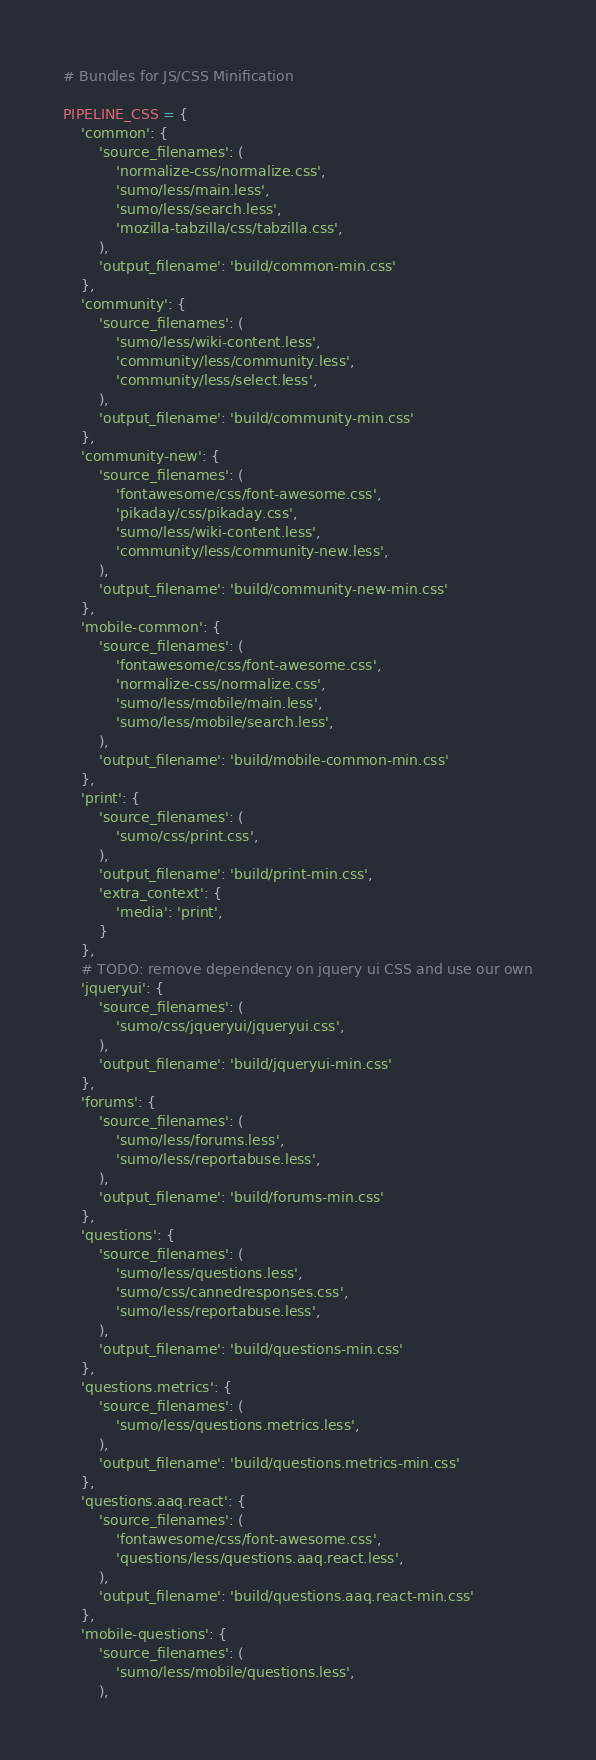<code> <loc_0><loc_0><loc_500><loc_500><_Python_># Bundles for JS/CSS Minification

PIPELINE_CSS = {
    'common': {
        'source_filenames': (
            'normalize-css/normalize.css',
            'sumo/less/main.less',
            'sumo/less/search.less',
            'mozilla-tabzilla/css/tabzilla.css',
        ),
        'output_filename': 'build/common-min.css'
    },
    'community': {
        'source_filenames': (
            'sumo/less/wiki-content.less',
            'community/less/community.less',
            'community/less/select.less',
        ),
        'output_filename': 'build/community-min.css'
    },
    'community-new': {
        'source_filenames': (
            'fontawesome/css/font-awesome.css',
            'pikaday/css/pikaday.css',
            'sumo/less/wiki-content.less',
            'community/less/community-new.less',
        ),
        'output_filename': 'build/community-new-min.css'
    },
    'mobile-common': {
        'source_filenames': (
            'fontawesome/css/font-awesome.css',
            'normalize-css/normalize.css',
            'sumo/less/mobile/main.less',
            'sumo/less/mobile/search.less',
        ),
        'output_filename': 'build/mobile-common-min.css'
    },
    'print': {
        'source_filenames': (
            'sumo/css/print.css',
        ),
        'output_filename': 'build/print-min.css',
        'extra_context': {
            'media': 'print',
        }
    },
    # TODO: remove dependency on jquery ui CSS and use our own
    'jqueryui': {
        'source_filenames': (
            'sumo/css/jqueryui/jqueryui.css',
        ),
        'output_filename': 'build/jqueryui-min.css'
    },
    'forums': {
        'source_filenames': (
            'sumo/less/forums.less',
            'sumo/less/reportabuse.less',
        ),
        'output_filename': 'build/forums-min.css'
    },
    'questions': {
        'source_filenames': (
            'sumo/less/questions.less',
            'sumo/css/cannedresponses.css',
            'sumo/less/reportabuse.less',
        ),
        'output_filename': 'build/questions-min.css'
    },
    'questions.metrics': {
        'source_filenames': (
            'sumo/less/questions.metrics.less',
        ),
        'output_filename': 'build/questions.metrics-min.css'
    },
    'questions.aaq.react': {
        'source_filenames': (
            'fontawesome/css/font-awesome.css',
            'questions/less/questions.aaq.react.less',
        ),
        'output_filename': 'build/questions.aaq.react-min.css'
    },
    'mobile-questions': {
        'source_filenames': (
            'sumo/less/mobile/questions.less',
        ),</code> 